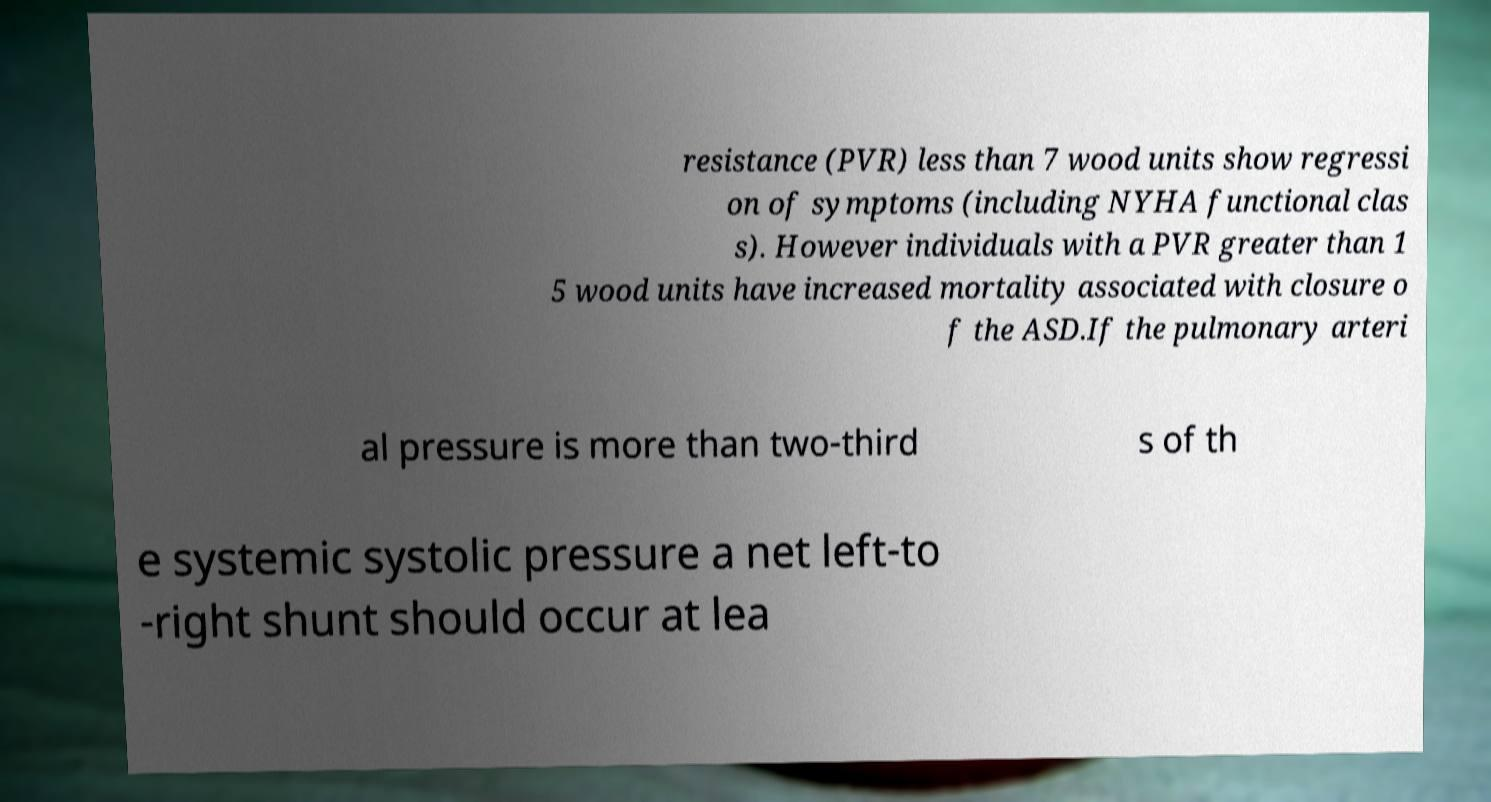For documentation purposes, I need the text within this image transcribed. Could you provide that? resistance (PVR) less than 7 wood units show regressi on of symptoms (including NYHA functional clas s). However individuals with a PVR greater than 1 5 wood units have increased mortality associated with closure o f the ASD.If the pulmonary arteri al pressure is more than two-third s of th e systemic systolic pressure a net left-to -right shunt should occur at lea 